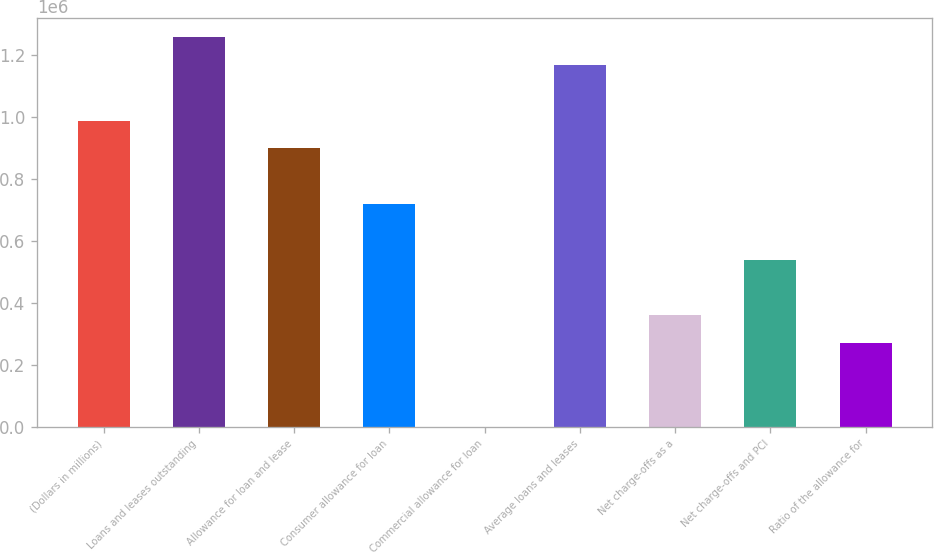<chart> <loc_0><loc_0><loc_500><loc_500><bar_chart><fcel>(Dollars in millions)<fcel>Loans and leases outstanding<fcel>Allowance for loan and lease<fcel>Consumer allowance for loan<fcel>Commercial allowance for loan<fcel>Average loans and leases<fcel>Net charge-offs as a<fcel>Net charge-offs and PCI<fcel>Ratio of the allowance for<nl><fcel>988699<fcel>1.25834e+06<fcel>898817<fcel>719054<fcel>0.9<fcel>1.16846e+06<fcel>359527<fcel>539291<fcel>269646<nl></chart> 